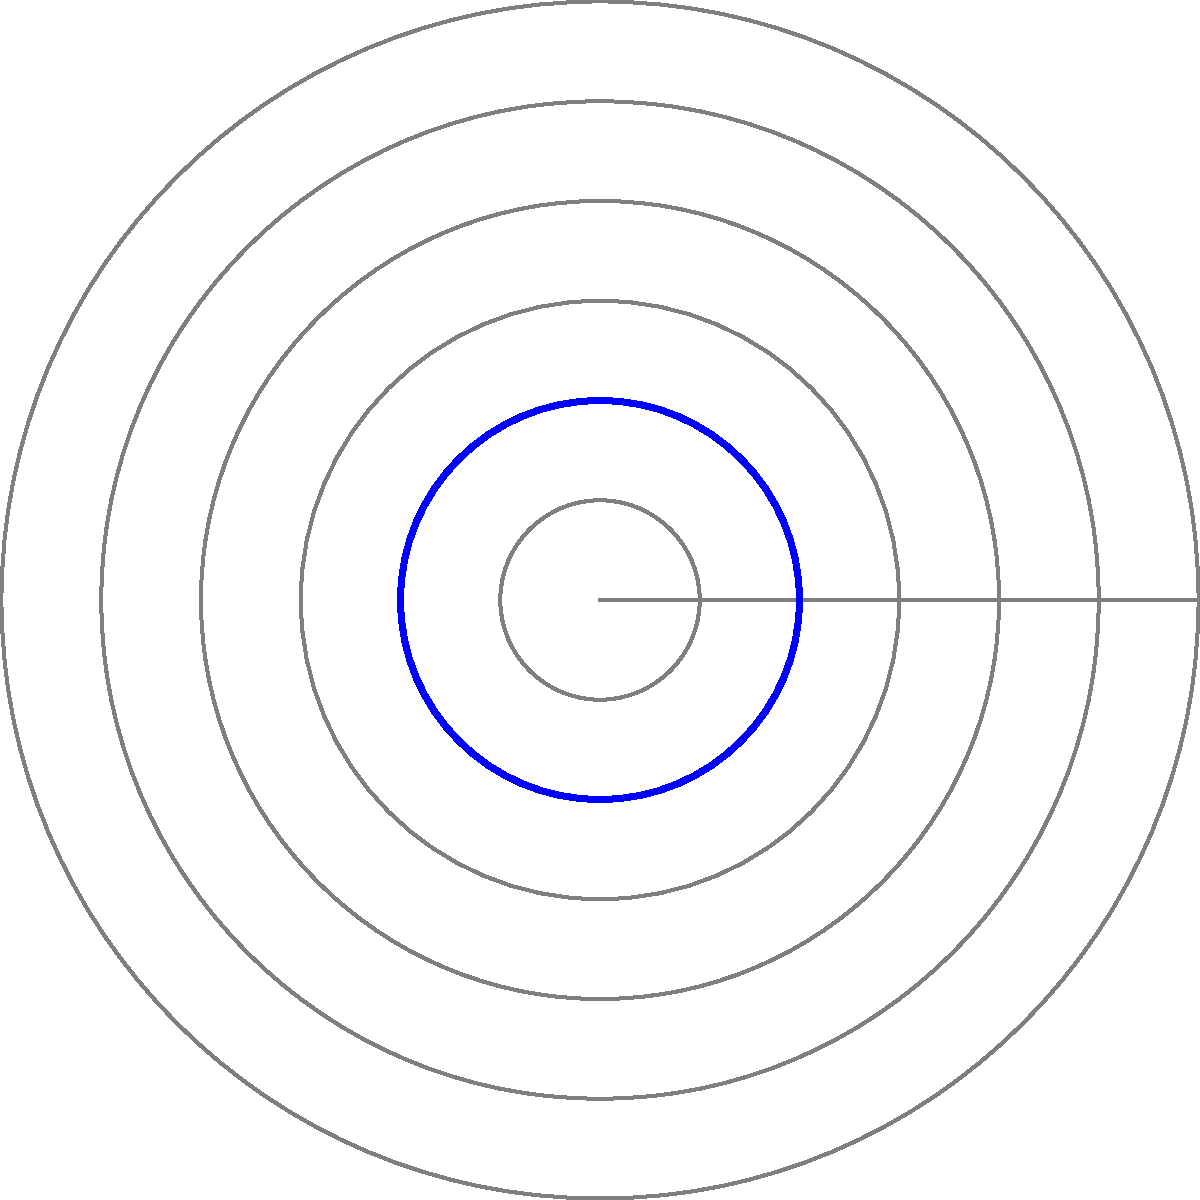In the polar graph representing a hockey goalie's movement pattern in the crease, what is the maximum radial distance (in units) reached by the goalie, and at which angle(s) does this occur? To answer this question, we need to analyze the polar graph representing the goalie's movement pattern. Let's break it down step-by-step:

1. The graph shows a closed path in red, representing the goalie's movement within the crease.

2. The radial distances are represented by the concentric circles, with values increasing from 0.5 to 3 units in steps of 0.5.

3. The angles are marked every 45°, starting from 0° and going counterclockwise.

4. We need to identify the points on the red path that are farthest from the center (origin).

5. Examining the graph, we can see that the path reaches its maximum distance from the center at two points:
   a. At approximately 135° (between 90° and 180°)
   b. At approximately 315° (between 270° and 360°/0°)

6. At both these points, the path touches the circle with a radius of 2.5 units.

Therefore, the maximum radial distance reached by the goalie is 2.5 units, and this occurs at two angles: approximately 135° and 315°.
Answer: 2.5 units at 135° and 315° 